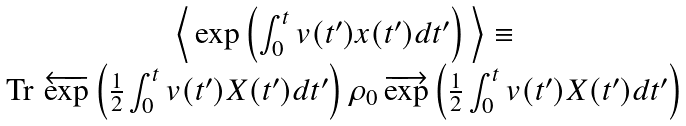<formula> <loc_0><loc_0><loc_500><loc_500>\begin{array} { c } \left \langle \, \exp \left ( \int _ { 0 } ^ { t } v ( t ^ { \prime } ) x ( t ^ { \prime } ) d t ^ { \prime } \right ) \, \right \rangle \equiv \\ \text {Tr\,} \, \overleftarrow { \exp } \left ( \frac { 1 } { 2 } \int _ { 0 } ^ { t } v ( t ^ { \prime } ) X ( t ^ { \prime } ) d t ^ { \prime } \right ) \rho _ { 0 } \, \overrightarrow { \exp } \left ( \frac { 1 } { 2 } \int _ { 0 } ^ { t } v ( t ^ { \prime } ) X ( t ^ { \prime } ) d t ^ { \prime } \right ) \end{array}</formula> 